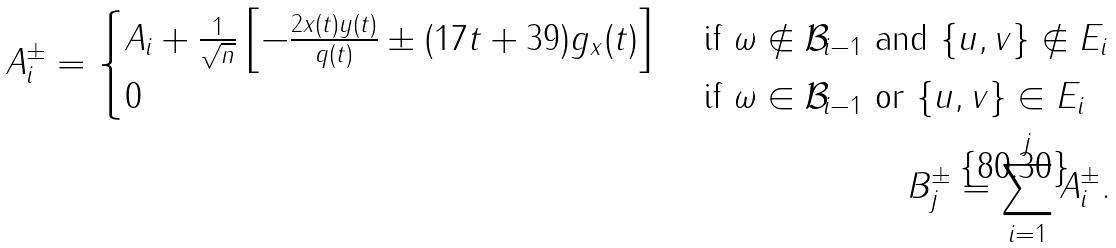<formula> <loc_0><loc_0><loc_500><loc_500>A ^ { \pm } _ { i } = \begin{cases} A _ { i } + \frac { 1 } { \sqrt { n } } \left [ - \frac { 2 x ( t ) y ( t ) } { q ( t ) } \pm ( 1 7 t + 3 9 ) g _ { x } ( t ) \right ] & \text { if } \omega \not \in { \mathcal { B } } _ { i - 1 } \text { and } \{ u , v \} \not \in E _ { i } \\ 0 & \text { if } \omega \in { \mathcal { B } } _ { i - 1 } \text { or } \{ u , v \} \in E _ { i } \end{cases} \\ B ^ { \pm } _ { j } = \sum _ { i = 1 } ^ { j } A ^ { \pm } _ { i } .</formula> 